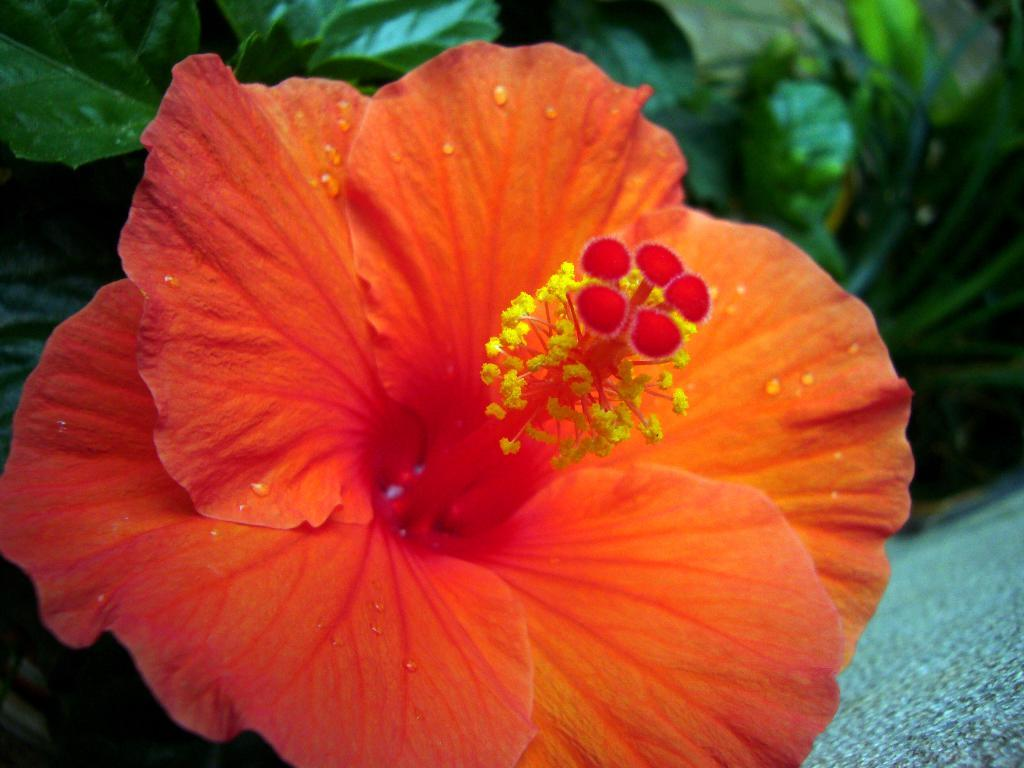What type of flower is in the image? There is a hibiscus flower in the image. What else can be seen in the image besides the hibiscus flower? There are plants visible in the image. What is the name of the hall where the hibiscus flower is located in the image? There is no hall mentioned or depicted in the image; it only shows a hibiscus flower and other plants. 